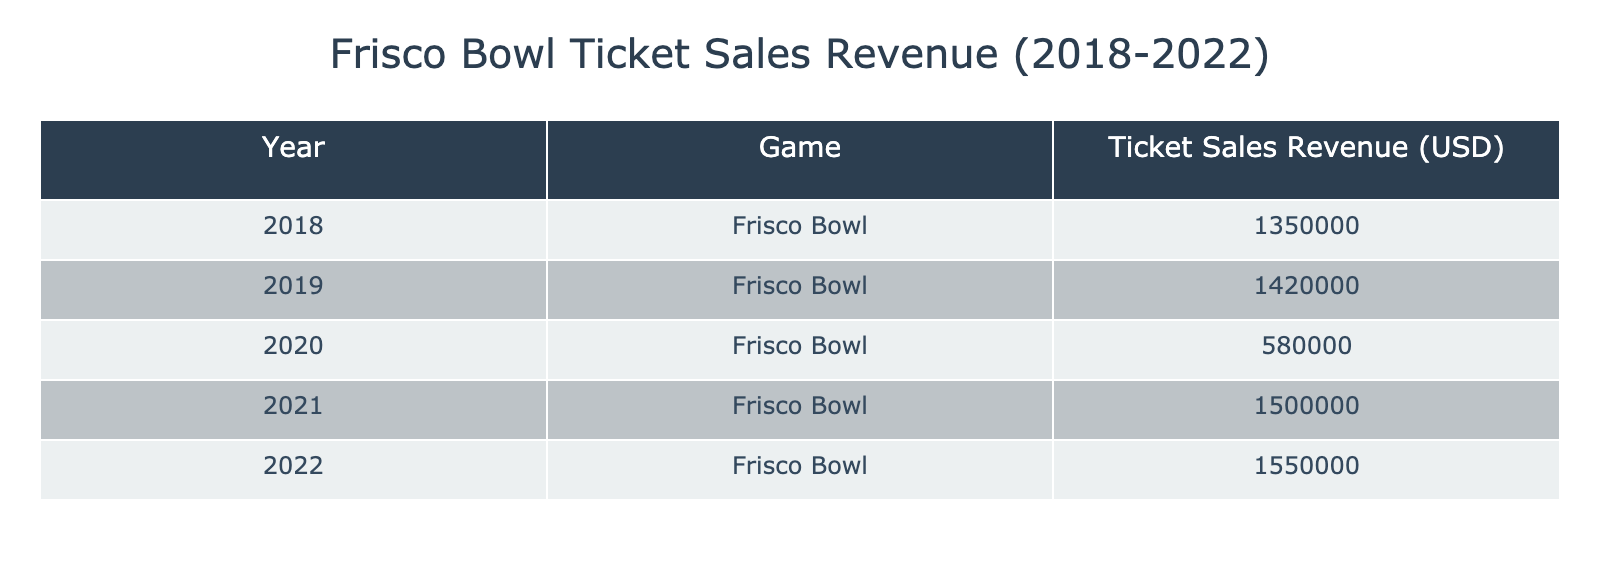What was the ticket sales revenue for the Frisco Bowl in 2019? The data for 2019 shows the ticket sales revenue amount as 1,420,000 USD. This is directly available in the table under the corresponding year.
Answer: 1,420,000 USD What year had the lowest ticket sales revenue and what was the amount? The lowest ticket sales revenue is found in the year 2020, where the amount was 580,000 USD. A quick look at the values in the table shows this is the smallest figure.
Answer: 2020, 580,000 USD What was the total ticket sales revenue for all Frisco Bowl games from 2018 to 2022? To find the total ticket sales revenue, sum the amounts for each year: 1,350,000 + 1,420,000 + 580,000 + 1,500,000 + 1,550,000. The total equals 6,400,000 USD.
Answer: 6,400,000 USD Was the ticket sales revenue in 2021 higher than that in 2018? The revenue for 2021 was 1,500,000 USD and for 2018 it was 1,350,000 USD. Since 1,500,000 is greater than 1,350,000, the statement is true.
Answer: Yes What is the average ticket sales revenue for the Frisco Bowl games from 2018 to 2022? There are five years of data, so to find the average, first sum the revenues (6,400,000 USD) and then divide by the number of years (5). This results in 1,280,000 USD as the average ticket sales revenue.
Answer: 1,280,000 USD Which year had a revenue increase from the previous year? For each year, look at the ticket sales revenue compared to the previous year: 2019 (1,420,000) > 2018 (1,350,000), 2021 (1,500,000) > 2020 (580,000), 2022 (1,550,000) > 2021 (1,500,000). Therefore, the years 2019, 2021, and 2022 had revenue increases from their respective previous years.
Answer: 2019, 2021, 2022 Did any year have ticket sales revenue less than 600,000? In the data provided, the only year with less than 600,000 USD was 2020, which had a revenue of 580,000 USD. This shows that 2020 is indeed below the threshold mentioned.
Answer: Yes In which year did ticket sales revenue surpass 1,500,000 for the first time? Reviewing the table, the revenue first exceeds 1,500,000 in 2021 since the revenue for 2020 was only 580,000. Thus, the first instance of exceeding 1,500,000 occurs in 2021.
Answer: 2021 